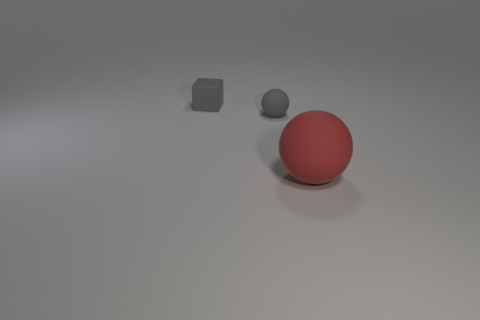What number of big red balls are there?
Offer a very short reply. 1. There is a rubber ball on the left side of the red matte ball; is its size the same as the red matte object?
Ensure brevity in your answer.  No. How many matte things are either gray spheres or gray cubes?
Offer a terse response. 2. What number of objects are on the left side of the sphere that is behind the red sphere?
Make the answer very short. 1. There is a sphere behind the big rubber sphere in front of the rubber ball that is left of the red matte object; what is it made of?
Your response must be concise. Rubber. There is a ball that is the same color as the block; what is its size?
Ensure brevity in your answer.  Small. What material is the tiny gray ball?
Provide a short and direct response. Rubber. Does the large red thing have the same material as the small object behind the tiny gray matte ball?
Your answer should be compact. Yes. What color is the thing in front of the rubber sphere left of the big red ball?
Provide a succinct answer. Red. There is a thing that is both to the right of the small matte cube and behind the red sphere; what size is it?
Give a very brief answer. Small. 